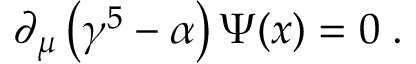Convert formula to latex. <formula><loc_0><loc_0><loc_500><loc_500>\partial _ { \mu } \left ( \gamma ^ { 5 } - \alpha \right ) \Psi ( x ) = 0 \, .</formula> 